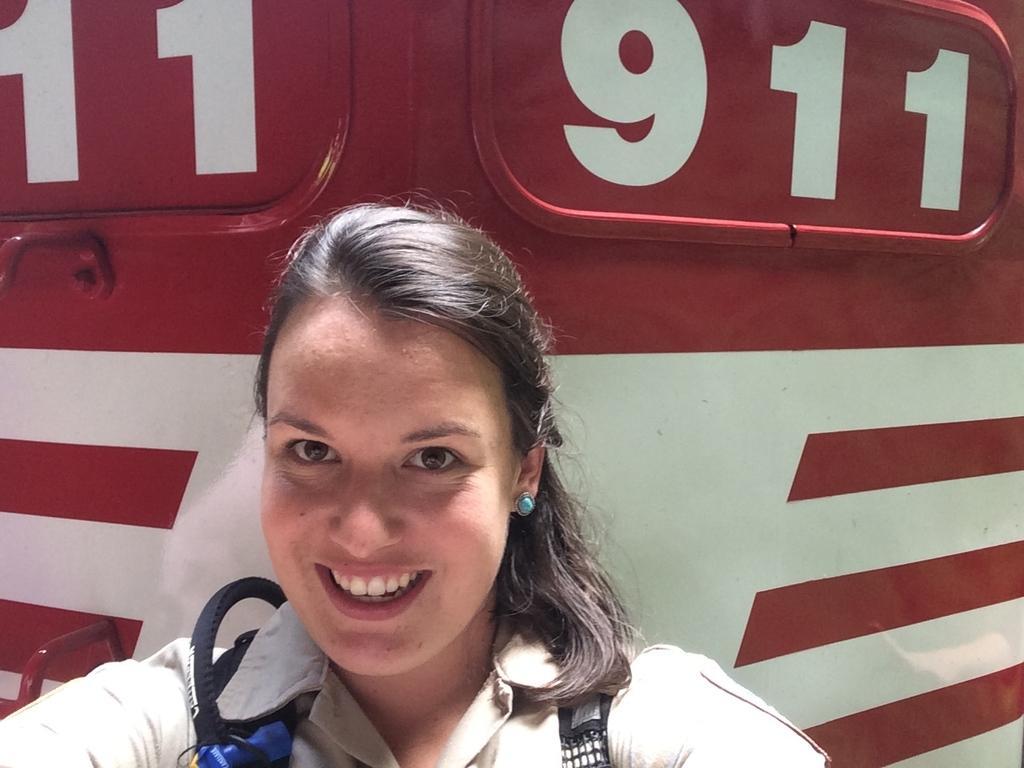Can you describe this image briefly? In this picture I can see a woman is smiling. In the background I can see an object. 